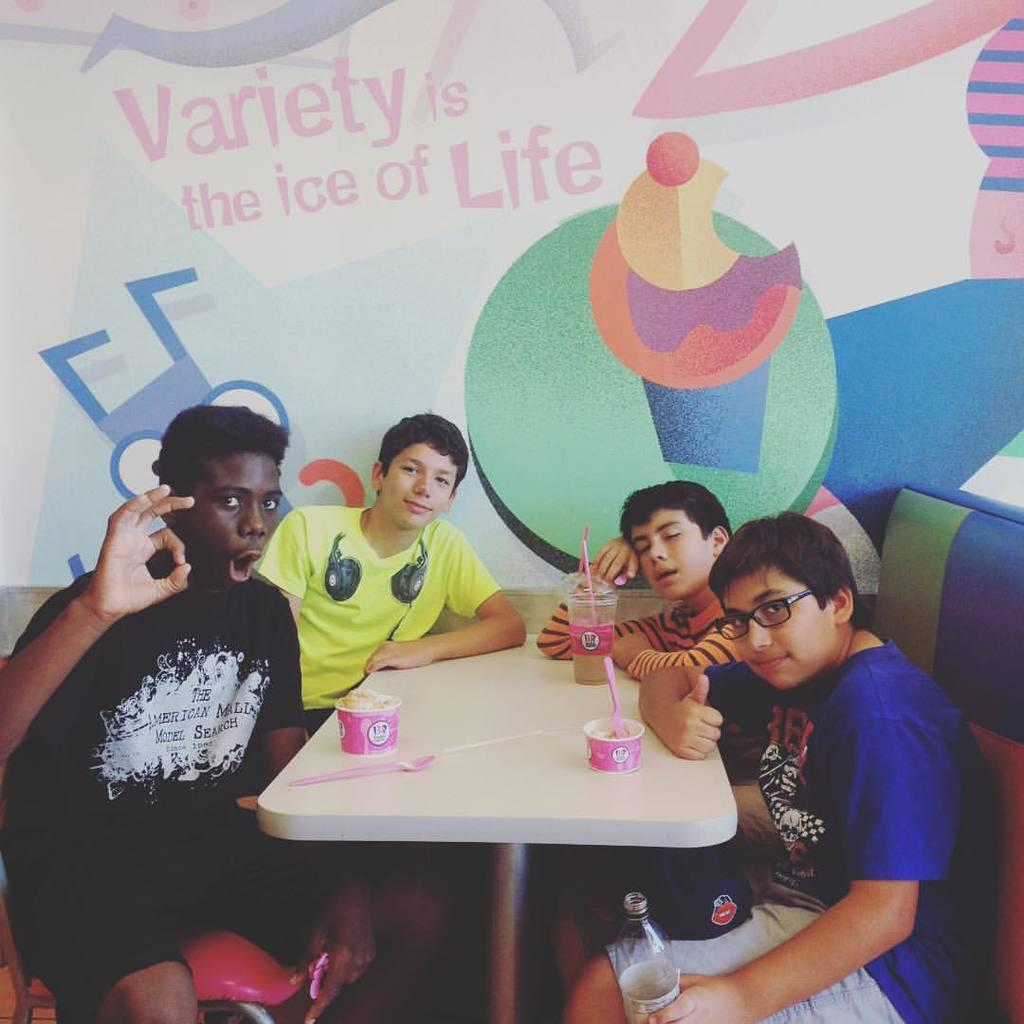How many boys are present in the image? There are 4 boys in the image. What are the boys doing in the image? The boys are sitting in chairs. What can be seen on the table in the image? There is a cup of food, spoons, and a glass on the table. What is visible on the wall in the background? There is wallpaper in the background. What is the most efficient route to take from the table to the door in the image? There is no door visible in the image, so it is not possible to determine the most efficient route to the door. 